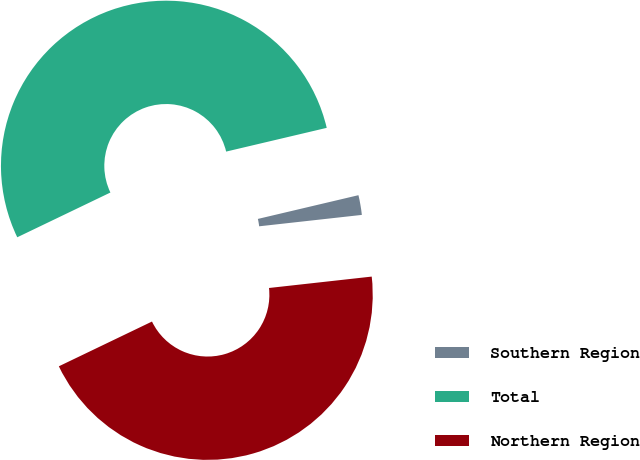Convert chart. <chart><loc_0><loc_0><loc_500><loc_500><pie_chart><fcel>Southern Region<fcel>Total<fcel>Northern Region<nl><fcel>1.93%<fcel>53.44%<fcel>44.63%<nl></chart> 